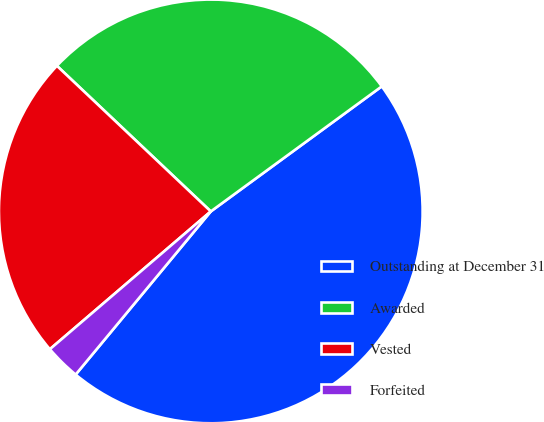Convert chart to OTSL. <chart><loc_0><loc_0><loc_500><loc_500><pie_chart><fcel>Outstanding at December 31<fcel>Awarded<fcel>Vested<fcel>Forfeited<nl><fcel>46.06%<fcel>27.89%<fcel>23.33%<fcel>2.72%<nl></chart> 